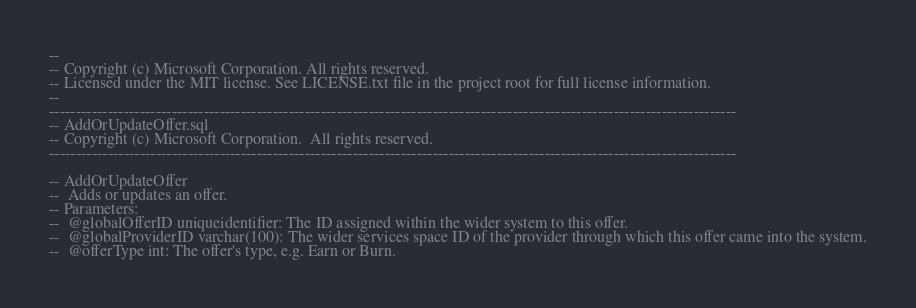<code> <loc_0><loc_0><loc_500><loc_500><_SQL_>--
-- Copyright (c) Microsoft Corporation. All rights reserved. 
-- Licensed under the MIT license. See LICENSE.txt file in the project root for full license information.
--
---------------------------------------------------------------------------------------------------------------------------------
-- AddOrUpdateOffer.sql
-- Copyright (c) Microsoft Corporation.  All rights reserved.  
---------------------------------------------------------------------------------------------------------------------------------

-- AddOrUpdateOffer
--  Adds or updates an offer.
-- Parameters:
--  @globalOfferID uniqueidentifier: The ID assigned within the wider system to this offer.
--  @globalProviderID varchar(100): The wider services space ID of the provider through which this offer came into the system.
--  @offerType int: The offer's type, e.g. Earn or Burn.</code> 